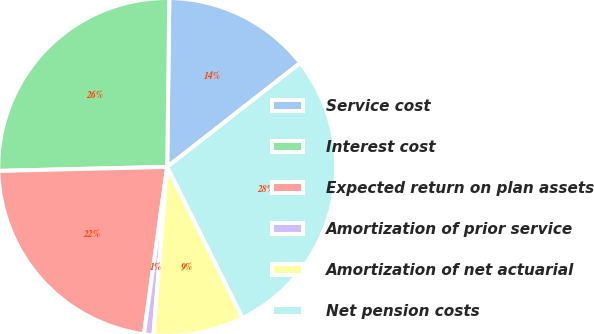<chart> <loc_0><loc_0><loc_500><loc_500><pie_chart><fcel>Service cost<fcel>Interest cost<fcel>Expected return on plan assets<fcel>Amortization of prior service<fcel>Amortization of net actuarial<fcel>Net pension costs<nl><fcel>14.25%<fcel>25.57%<fcel>22.42%<fcel>0.9%<fcel>8.67%<fcel>28.18%<nl></chart> 